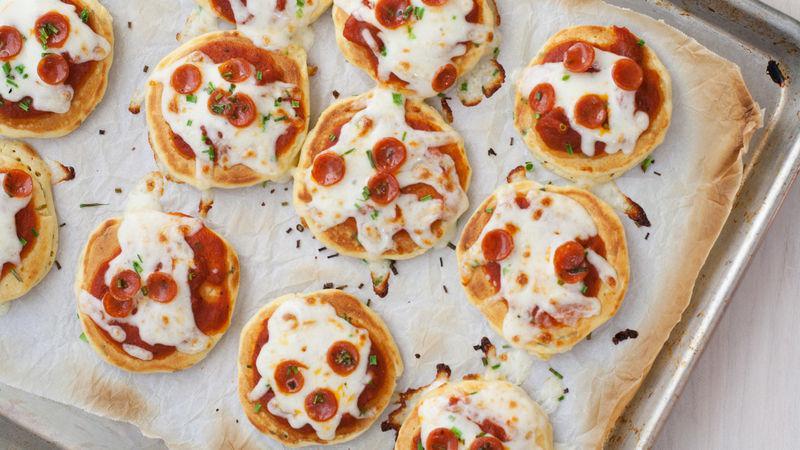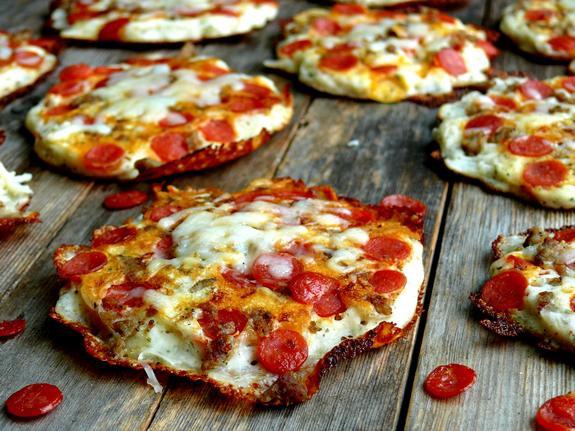The first image is the image on the left, the second image is the image on the right. Given the left and right images, does the statement "In the left image, there is more than one individual pizza." hold true? Answer yes or no. Yes. The first image is the image on the left, the second image is the image on the right. Given the left and right images, does the statement "There is pepperoni on the table." hold true? Answer yes or no. Yes. 